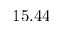<formula> <loc_0><loc_0><loc_500><loc_500>1 5 . 4 4</formula> 